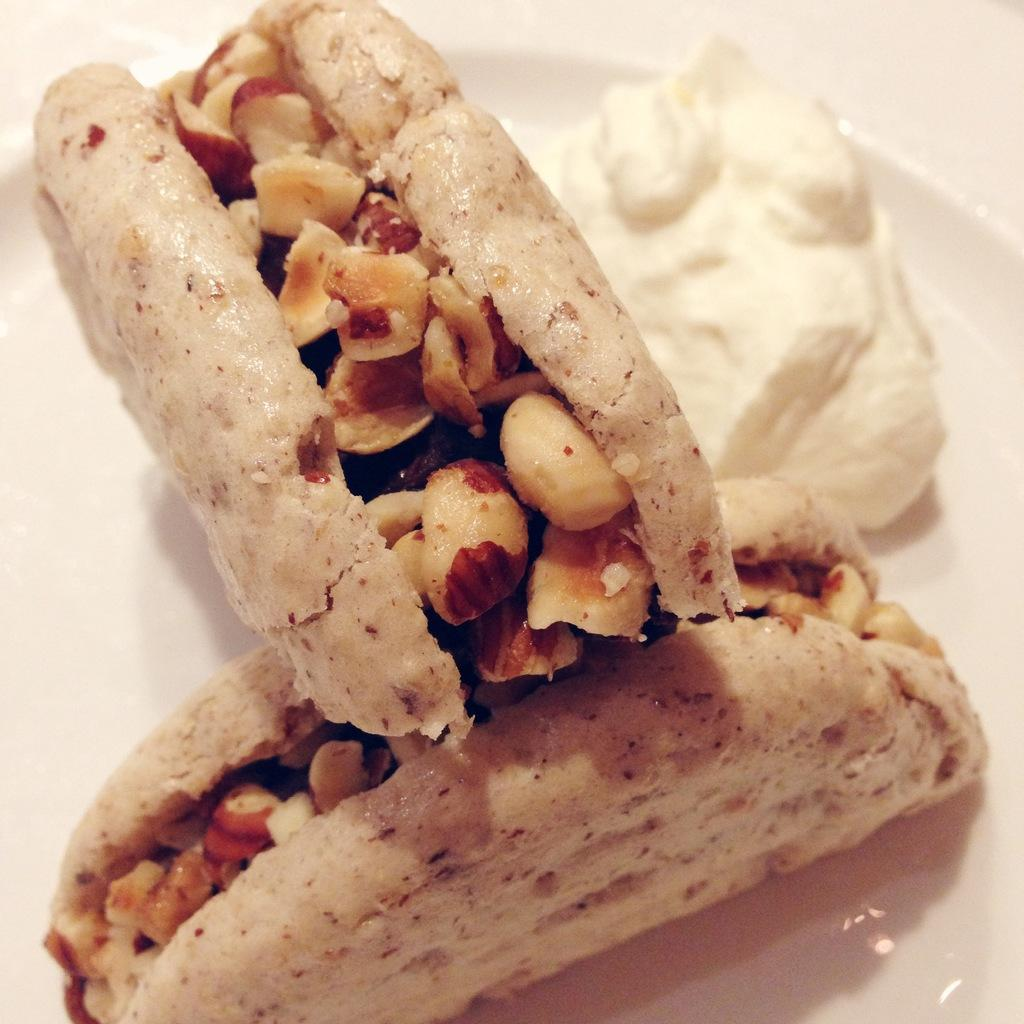What is on the plate that is visible in the image? There are food items on a plate in the image. What is the color of the plate? The plate is white. What type of hall can be seen in the image? There is no hall present in the image; it only features a plate with food items. How does the growth of the food items appear in the image? The image does not show the growth of the food items, as it only depicts the food items on a plate. 